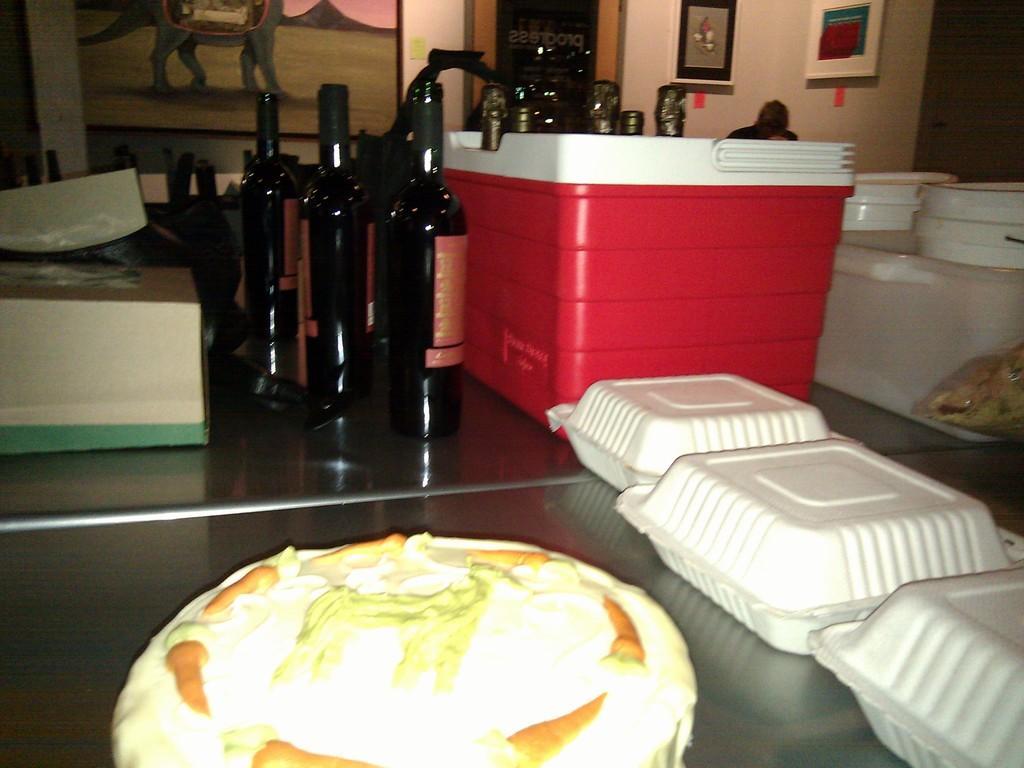Can you describe this image briefly? In this image there are 3 wine bottles, food, paper plates , container , box in the table , and in back ground there are buckets , frames attached to wall , door. 